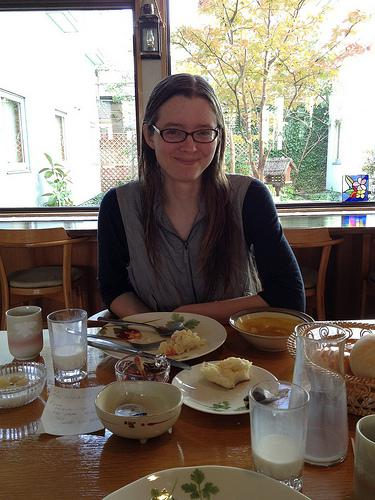Please describe the drink and its surroundings in the image. A partially drank glass of milk is on a wooden table, near a smiling woman wearing glasses, and a flower stain glass window decoration. Who and what is depicted in the center of the image? A light-skinned woman with long brown hair wearing spectacles, sitting at a wooden table. List objects related to the appearance and clothing of the person in the image. Long brown hair, black glasses, and light-skinned woman. Identify objects related to food or drink in this picture. A partially drank glass of milk, a bowl with clear soup, a pitcher with milk residue, left over bread on a plate, and a basket with untouched bread. Give me a brief overview of the objects on the table in the image. There is a partially drank glass of milk, a saucer with a leaf print, a spoon on a plate, and a note on the brown wooden table. Tell me about the hair of the woman in the picture and an accessory she is wearing. The woman has long brown hair and is wearing black-framed glasses. What is a noticeable feature about the woman's face in the image? The woman has a closed mouth and is wearing spectacles. What is the main focus of the image? A smiling woman with long brown hair sitting at a brown wooden table, wearing black glasses. Have you looked at the red polka-dotted umbrella hanging by the door? It's just so vibrant and colorful! No, it's not mentioned in the image. 